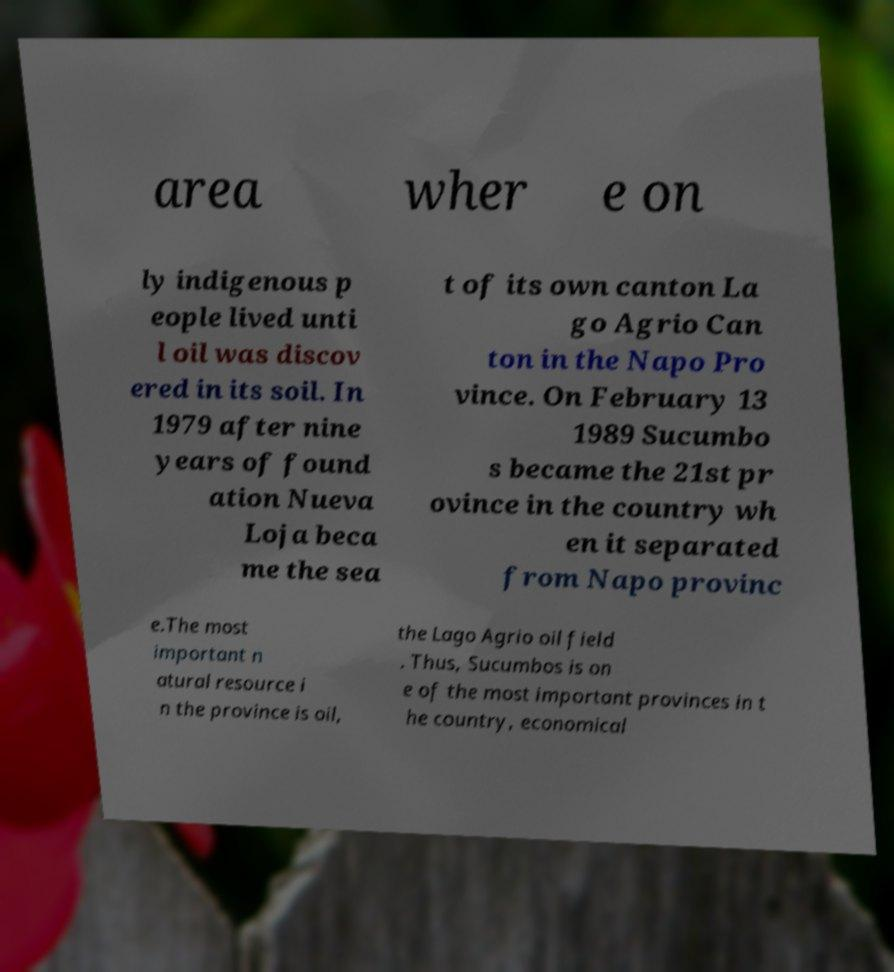Could you assist in decoding the text presented in this image and type it out clearly? area wher e on ly indigenous p eople lived unti l oil was discov ered in its soil. In 1979 after nine years of found ation Nueva Loja beca me the sea t of its own canton La go Agrio Can ton in the Napo Pro vince. On February 13 1989 Sucumbo s became the 21st pr ovince in the country wh en it separated from Napo provinc e.The most important n atural resource i n the province is oil, the Lago Agrio oil field . Thus, Sucumbos is on e of the most important provinces in t he country, economical 